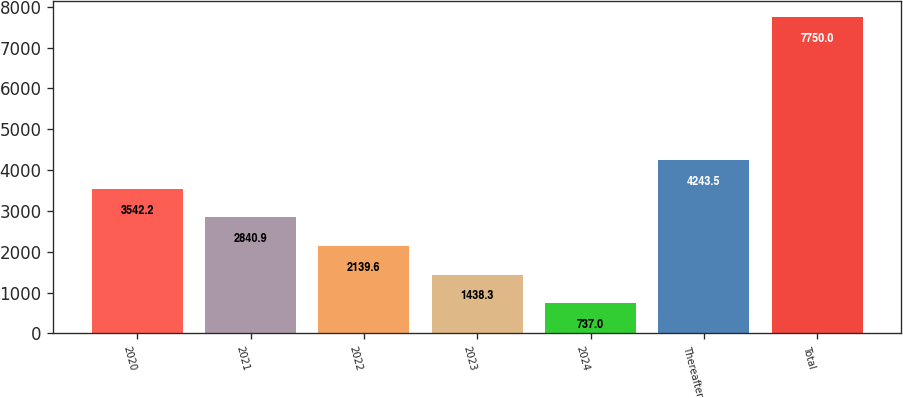<chart> <loc_0><loc_0><loc_500><loc_500><bar_chart><fcel>2020<fcel>2021<fcel>2022<fcel>2023<fcel>2024<fcel>Thereafter<fcel>Total<nl><fcel>3542.2<fcel>2840.9<fcel>2139.6<fcel>1438.3<fcel>737<fcel>4243.5<fcel>7750<nl></chart> 